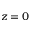Convert formula to latex. <formula><loc_0><loc_0><loc_500><loc_500>z = 0</formula> 